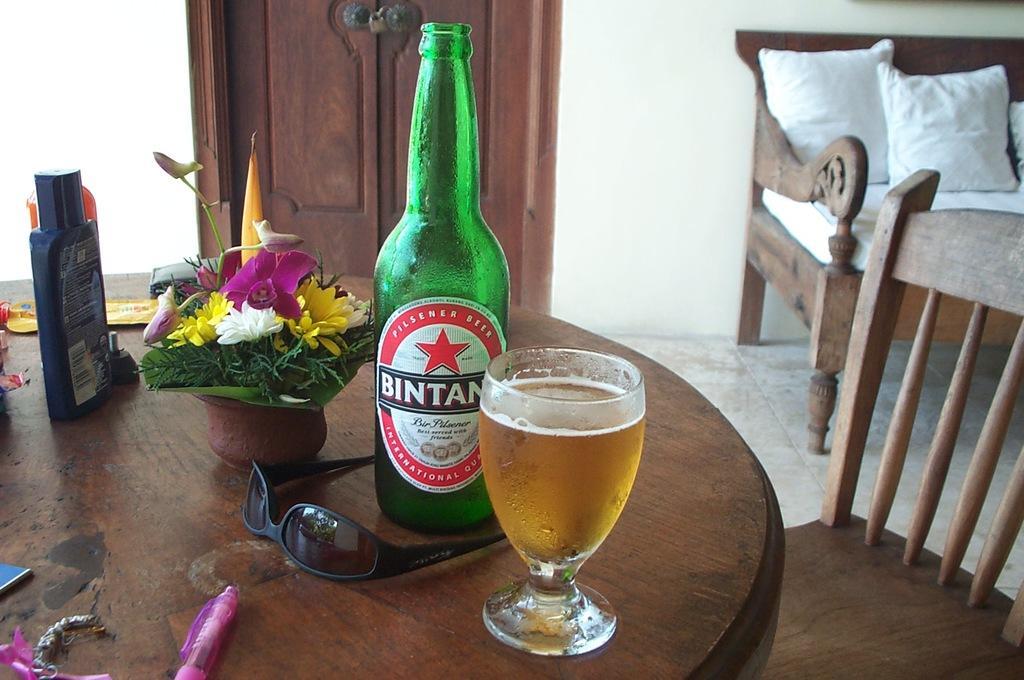How would you summarize this image in a sentence or two? In this image I can see there is a dining table on the floor. On that there are bottle, glass, pen, spectacles, flower pot and some objects. And at the side there is a chair and a sofa. And on the sofa there are pillows and bed. And at the back there is a wall and a door. 